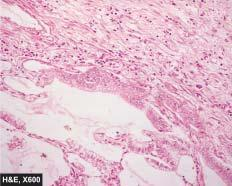what are lined by cuboidal to tall columnar and mucin-secreting tumour cells with papillary growth pattern?
Answer the question using a single word or phrase. Alveolar walls 